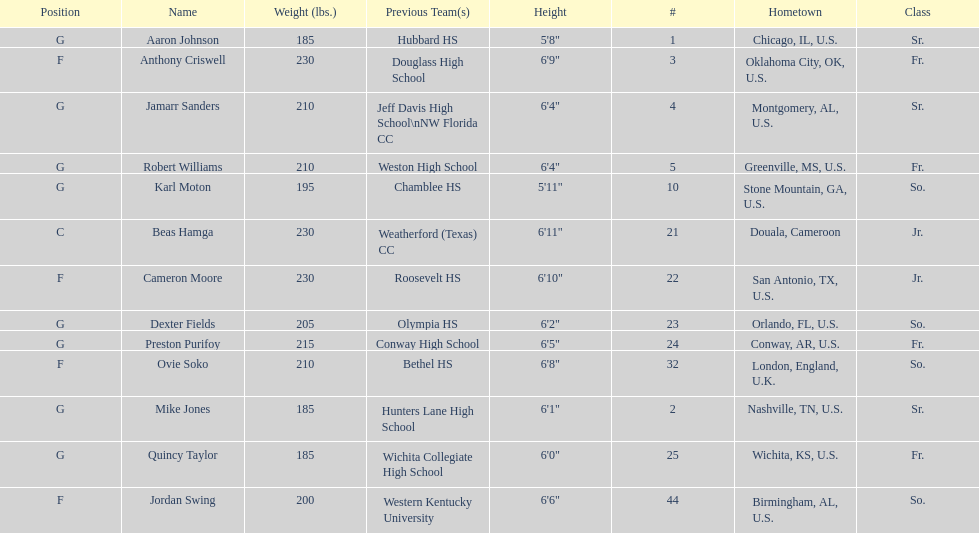Other than soko, tell me a player who is not from the us. Beas Hamga. 